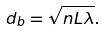Convert formula to latex. <formula><loc_0><loc_0><loc_500><loc_500>d _ { b } = \sqrt { n L \lambda } .</formula> 